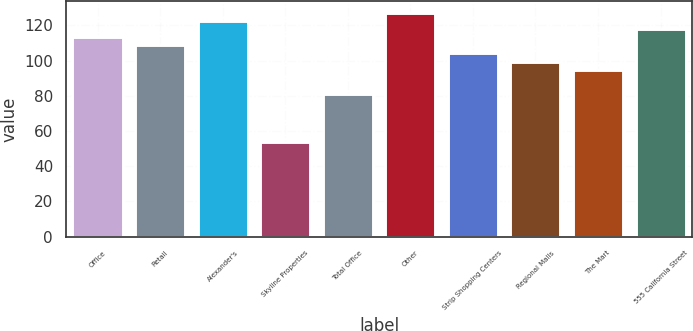Convert chart to OTSL. <chart><loc_0><loc_0><loc_500><loc_500><bar_chart><fcel>Office<fcel>Retail<fcel>Alexander's<fcel>Skyline Properties<fcel>Total Office<fcel>Other<fcel>Strip Shopping Centers<fcel>Regional Malls<fcel>The Mart<fcel>555 California Street<nl><fcel>113.3<fcel>108.65<fcel>122.6<fcel>53.5<fcel>80.9<fcel>127.25<fcel>104<fcel>99.35<fcel>94.7<fcel>117.95<nl></chart> 